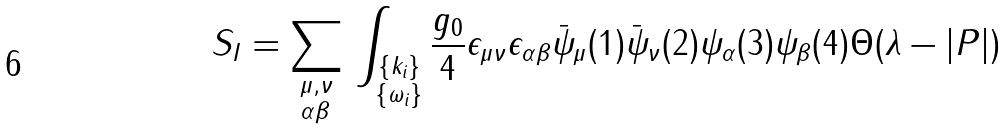<formula> <loc_0><loc_0><loc_500><loc_500>S _ { I } = \sum _ { \begin{subarray} { c } \mu , \nu \\ \alpha \beta \end{subarray} } \, \int _ { \substack { \{ k _ { i } \} \\ \{ \omega _ { i } \} } } \frac { g _ { 0 } } { 4 } \epsilon _ { \mu \nu } \epsilon _ { \alpha \beta } \bar { \psi } _ { \mu } ( 1 ) \bar { \psi } _ { \nu } ( 2 ) \psi _ { \alpha } ( 3 ) \psi _ { \beta } ( 4 ) \Theta ( \lambda - | P | )</formula> 